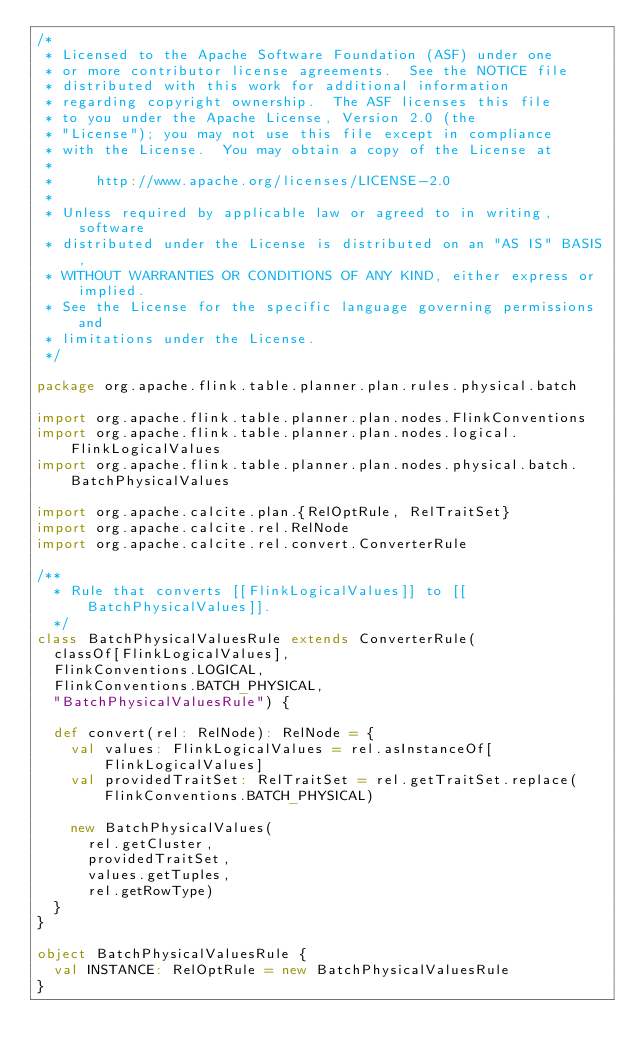<code> <loc_0><loc_0><loc_500><loc_500><_Scala_>/*
 * Licensed to the Apache Software Foundation (ASF) under one
 * or more contributor license agreements.  See the NOTICE file
 * distributed with this work for additional information
 * regarding copyright ownership.  The ASF licenses this file
 * to you under the Apache License, Version 2.0 (the
 * "License"); you may not use this file except in compliance
 * with the License.  You may obtain a copy of the License at
 *
 *     http://www.apache.org/licenses/LICENSE-2.0
 *
 * Unless required by applicable law or agreed to in writing, software
 * distributed under the License is distributed on an "AS IS" BASIS,
 * WITHOUT WARRANTIES OR CONDITIONS OF ANY KIND, either express or implied.
 * See the License for the specific language governing permissions and
 * limitations under the License.
 */

package org.apache.flink.table.planner.plan.rules.physical.batch

import org.apache.flink.table.planner.plan.nodes.FlinkConventions
import org.apache.flink.table.planner.plan.nodes.logical.FlinkLogicalValues
import org.apache.flink.table.planner.plan.nodes.physical.batch.BatchPhysicalValues

import org.apache.calcite.plan.{RelOptRule, RelTraitSet}
import org.apache.calcite.rel.RelNode
import org.apache.calcite.rel.convert.ConverterRule

/**
  * Rule that converts [[FlinkLogicalValues]] to [[BatchPhysicalValues]].
  */
class BatchPhysicalValuesRule extends ConverterRule(
  classOf[FlinkLogicalValues],
  FlinkConventions.LOGICAL,
  FlinkConventions.BATCH_PHYSICAL,
  "BatchPhysicalValuesRule") {

  def convert(rel: RelNode): RelNode = {
    val values: FlinkLogicalValues = rel.asInstanceOf[FlinkLogicalValues]
    val providedTraitSet: RelTraitSet = rel.getTraitSet.replace(FlinkConventions.BATCH_PHYSICAL)

    new BatchPhysicalValues(
      rel.getCluster,
      providedTraitSet,
      values.getTuples,
      rel.getRowType)
  }
}

object BatchPhysicalValuesRule {
  val INSTANCE: RelOptRule = new BatchPhysicalValuesRule
}
</code> 